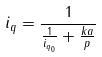Convert formula to latex. <formula><loc_0><loc_0><loc_500><loc_500>i _ { q } = \frac { 1 } { \frac { 1 } { i _ { q _ { 0 } } } + \frac { k a } { p } }</formula> 